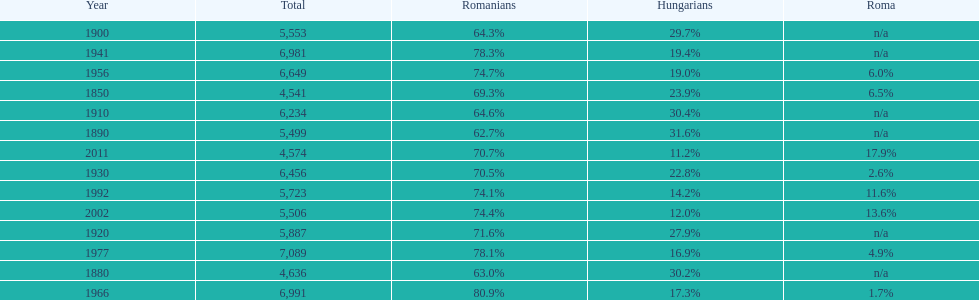What is the number of times the total population was 6,000 or more? 6. Would you mind parsing the complete table? {'header': ['Year', 'Total', 'Romanians', 'Hungarians', 'Roma'], 'rows': [['1900', '5,553', '64.3%', '29.7%', 'n/a'], ['1941', '6,981', '78.3%', '19.4%', 'n/a'], ['1956', '6,649', '74.7%', '19.0%', '6.0%'], ['1850', '4,541', '69.3%', '23.9%', '6.5%'], ['1910', '6,234', '64.6%', '30.4%', 'n/a'], ['1890', '5,499', '62.7%', '31.6%', 'n/a'], ['2011', '4,574', '70.7%', '11.2%', '17.9%'], ['1930', '6,456', '70.5%', '22.8%', '2.6%'], ['1992', '5,723', '74.1%', '14.2%', '11.6%'], ['2002', '5,506', '74.4%', '12.0%', '13.6%'], ['1920', '5,887', '71.6%', '27.9%', 'n/a'], ['1977', '7,089', '78.1%', '16.9%', '4.9%'], ['1880', '4,636', '63.0%', '30.2%', 'n/a'], ['1966', '6,991', '80.9%', '17.3%', '1.7%']]} 